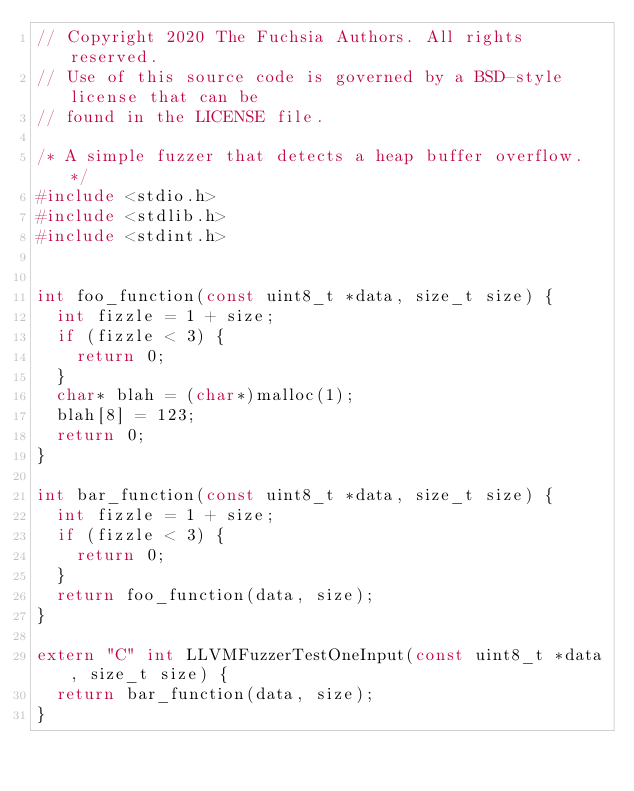<code> <loc_0><loc_0><loc_500><loc_500><_C++_>// Copyright 2020 The Fuchsia Authors. All rights reserved.
// Use of this source code is governed by a BSD-style license that can be
// found in the LICENSE file.

/* A simple fuzzer that detects a heap buffer overflow. */
#include <stdio.h>
#include <stdlib.h>
#include <stdint.h>


int foo_function(const uint8_t *data, size_t size) {
  int fizzle = 1 + size;
  if (fizzle < 3) {
  	return 0;
  }
  char* blah = (char*)malloc(1);
  blah[8] = 123;
  return 0;
}

int bar_function(const uint8_t *data, size_t size) {
  int fizzle = 1 + size;
  if (fizzle < 3) {
  	return 0;
  }
  return foo_function(data, size);
}

extern "C" int LLVMFuzzerTestOneInput(const uint8_t *data, size_t size) {
  return bar_function(data, size);
}

</code> 